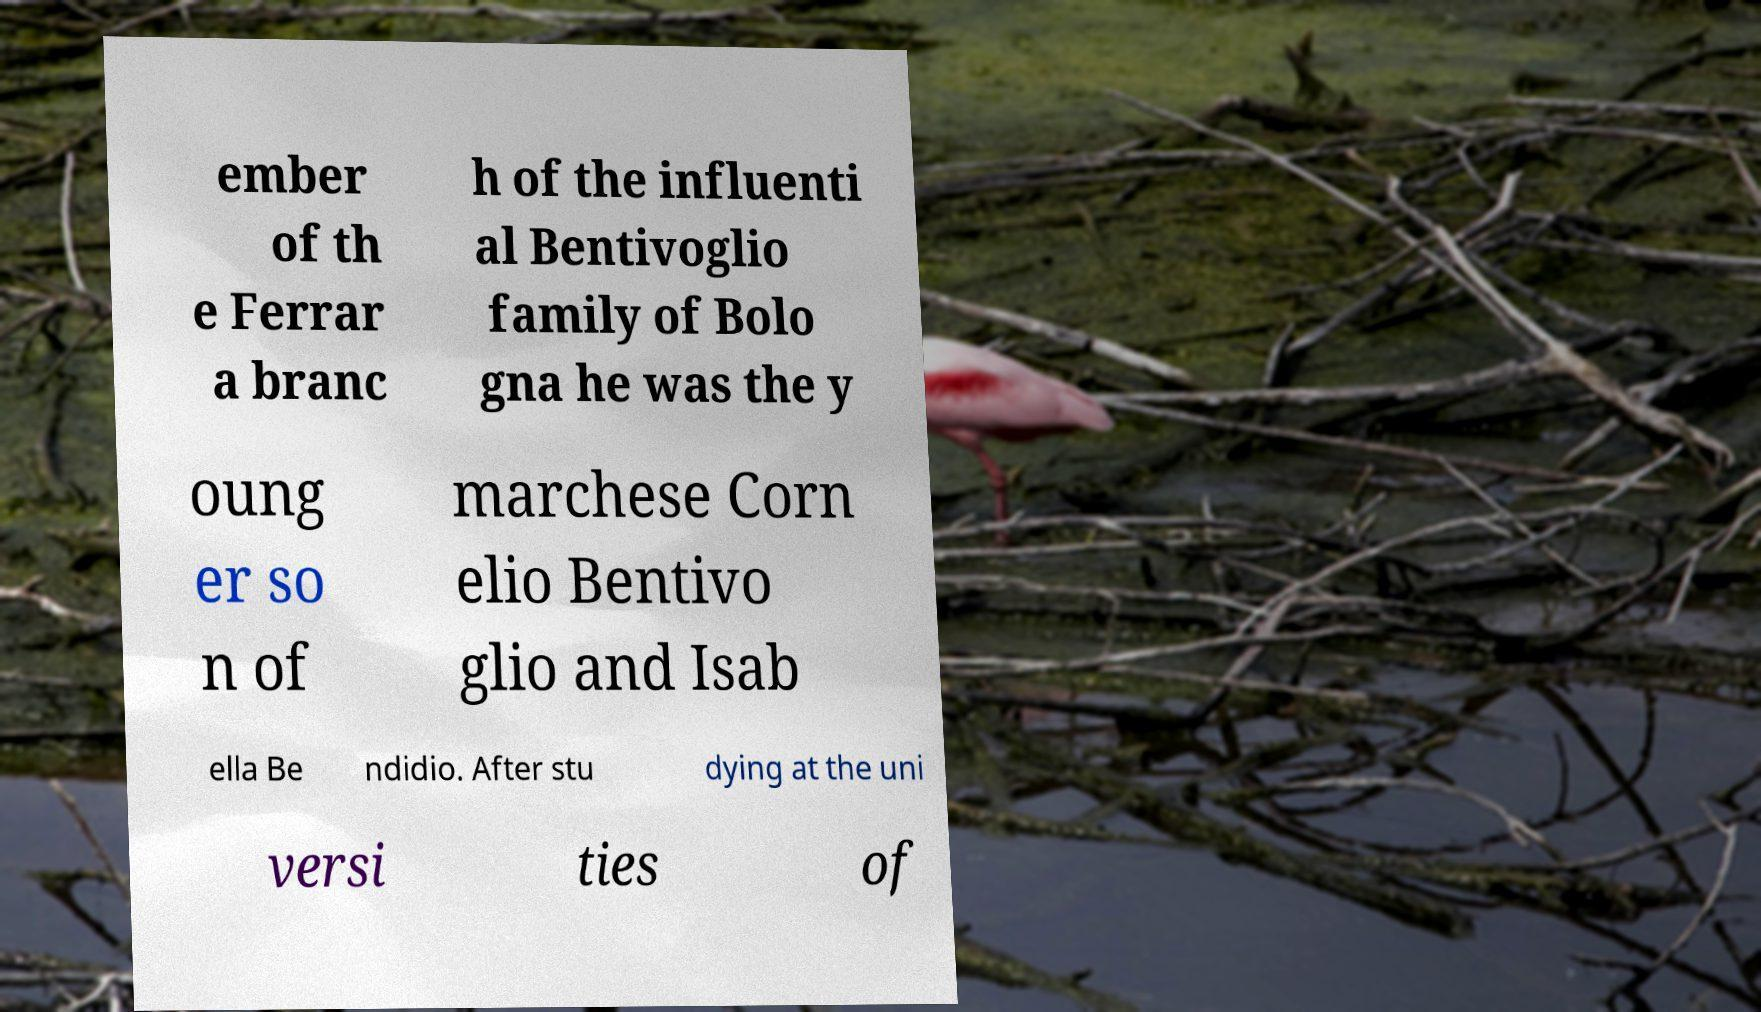What messages or text are displayed in this image? I need them in a readable, typed format. ember of th e Ferrar a branc h of the influenti al Bentivoglio family of Bolo gna he was the y oung er so n of marchese Corn elio Bentivo glio and Isab ella Be ndidio. After stu dying at the uni versi ties of 